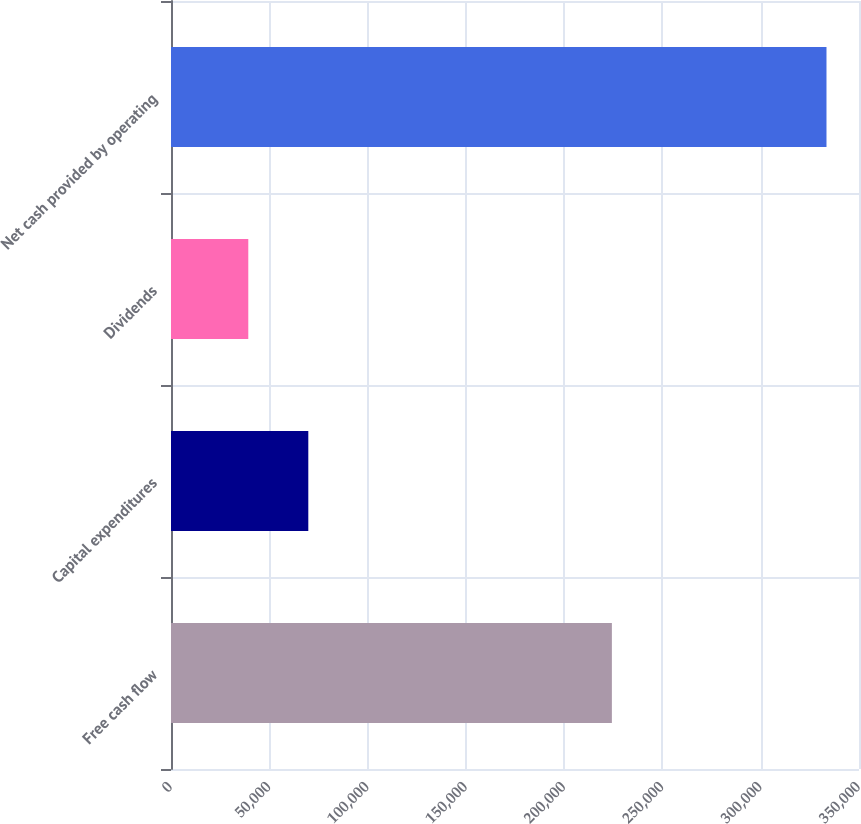Convert chart to OTSL. <chart><loc_0><loc_0><loc_500><loc_500><bar_chart><fcel>Free cash flow<fcel>Capital expenditures<fcel>Dividends<fcel>Net cash provided by operating<nl><fcel>224288<fcel>69851<fcel>39320<fcel>333459<nl></chart> 